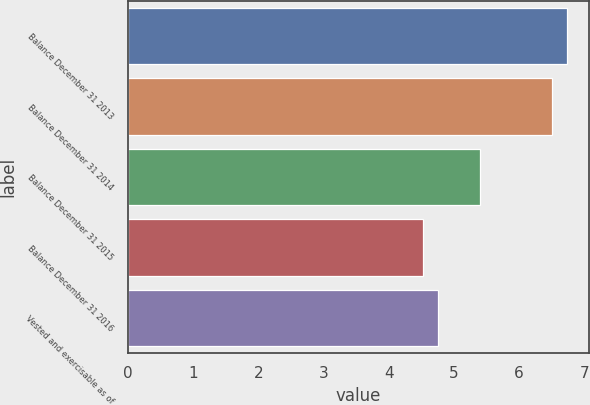Convert chart to OTSL. <chart><loc_0><loc_0><loc_500><loc_500><bar_chart><fcel>Balance December 31 2013<fcel>Balance December 31 2014<fcel>Balance December 31 2015<fcel>Balance December 31 2016<fcel>Vested and exercisable as of<nl><fcel>6.73<fcel>6.5<fcel>5.4<fcel>4.53<fcel>4.76<nl></chart> 